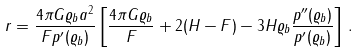<formula> <loc_0><loc_0><loc_500><loc_500>r = \frac { 4 \pi G \varrho _ { b } a ^ { 2 } } { F p ^ { \prime } ( \varrho _ { b } ) } \left [ \frac { 4 \pi G \varrho _ { b } } { F } + 2 ( H - F ) - 3 H \varrho _ { b } \frac { p ^ { \prime \prime } ( \varrho _ { b } ) } { p ^ { \prime } ( \varrho _ { b } ) } \right ] \, .</formula> 